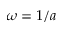<formula> <loc_0><loc_0><loc_500><loc_500>\omega = 1 / a</formula> 